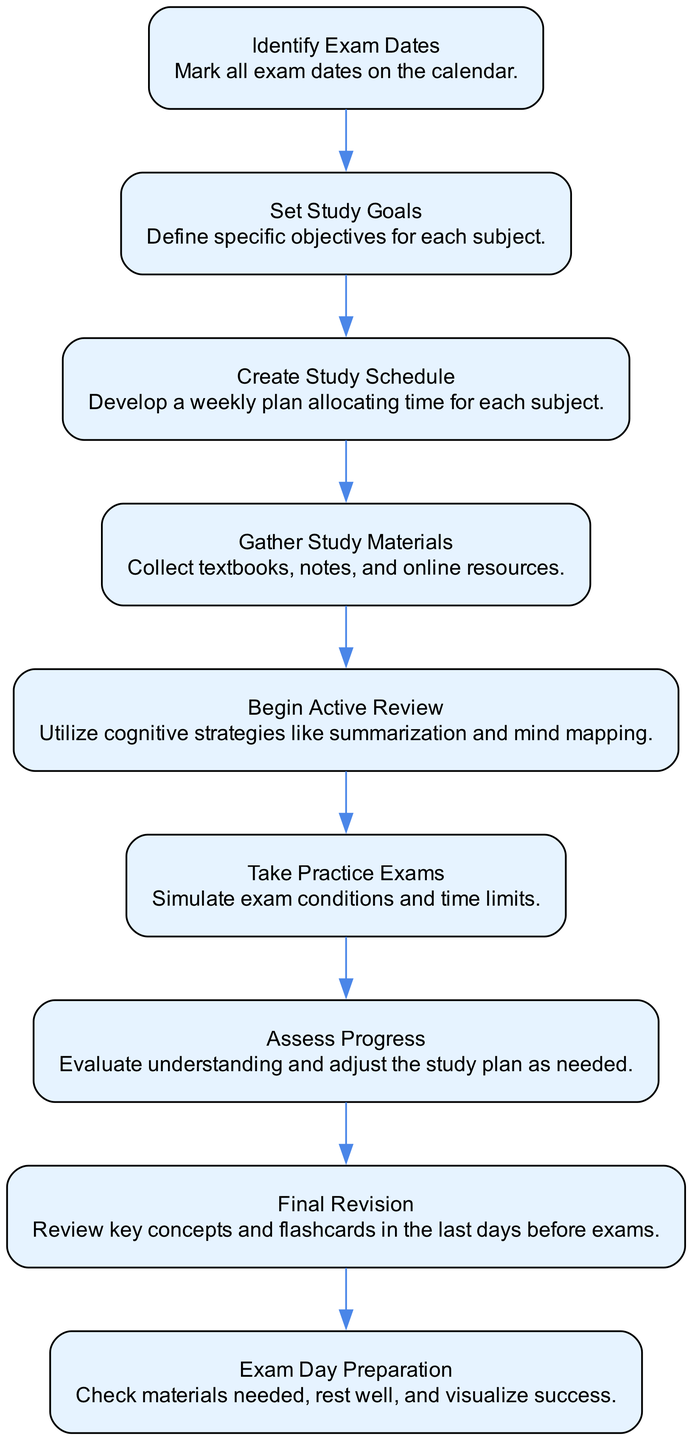What is the first step in the timeline? The diagram states the first step is to "Identify Exam Dates." This is explicitly labeled at the top of the flow chart.
Answer: Identify Exam Dates How many nodes are there in the diagram? By counting each step listed in the timeline, there are nine nodes corresponding to each step from "Identify Exam Dates" to "Exam Day Preparation."
Answer: 9 What step follows "Take Practice Exams"? The diagram indicates that the step following "Take Practice Exams" is "Assess Progress." This is shown as a direct flow from one node to the next.
Answer: Assess Progress What milestone comes before "Final Revision"? According to the flow of the diagram, "Assess Progress" is the milestone that comes right before "Final Revision." This can be traced back from the flow connected between the two nodes.
Answer: Assess Progress Which step involves collecting textbooks and online resources? The node labeled "Gather Study Materials" explicitly states the involvement of collecting textbooks, notes, and online resources. This is clearly outlined in the description of that step.
Answer: Gather Study Materials How would you describe the overall flow of the steps? The flow of the steps follows a sequential and logical progression, each step leads to the next in a linear fashion, culminating in the final preparations needed for exam day. This intuitive layout reflects a structured approach to exam preparation.
Answer: Sequential What cognitive strategies are suggested in the "Begin Active Review" step? The "Begin Active Review" step mentions utilizing cognitive strategies like summarization and mind mapping. These techniques are explicitly included in the description of that particular step in the diagram.
Answer: Summarization and mind mapping Which step emphasizes the importance of visualizing success? The step titled "Exam Day Preparation" emphasizes the importance of visualizing success, as stated in its description. It highlights that mental preparation is part of getting ready for the exam.
Answer: Exam Day Preparation What action is taken immediately after "Create Study Schedule"? The action taken immediately after "Create Study Schedule" is "Gather Study Materials," which directly follows in the order of the tasks outlined in the diagram.
Answer: Gather Study Materials 